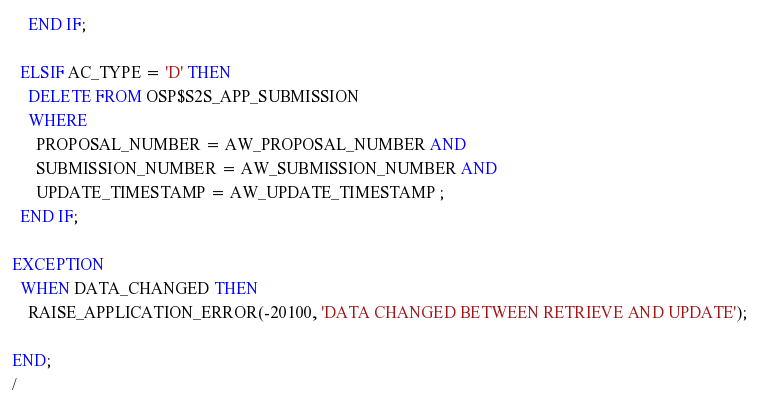Convert code to text. <code><loc_0><loc_0><loc_500><loc_500><_SQL_>    END IF;

  ELSIF AC_TYPE = 'D' THEN
    DELETE FROM OSP$S2S_APP_SUBMISSION
    WHERE
      PROPOSAL_NUMBER = AW_PROPOSAL_NUMBER AND
      SUBMISSION_NUMBER = AW_SUBMISSION_NUMBER AND
      UPDATE_TIMESTAMP = AW_UPDATE_TIMESTAMP ;
  END IF;

EXCEPTION
  WHEN DATA_CHANGED THEN
    RAISE_APPLICATION_ERROR(-20100, 'DATA CHANGED BETWEEN RETRIEVE AND UPDATE');

END;
/

</code> 